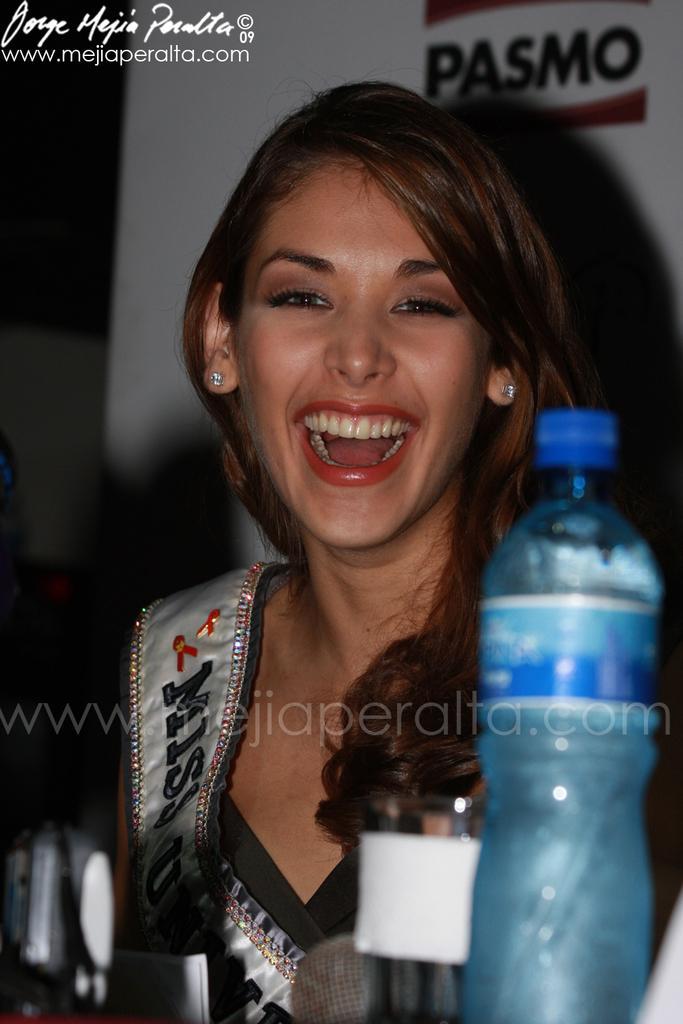Can you describe this image briefly? In the picture a woman is smiling. In the foreground there is a water bottle. In the background there is banner. On the top left there is a text written. 